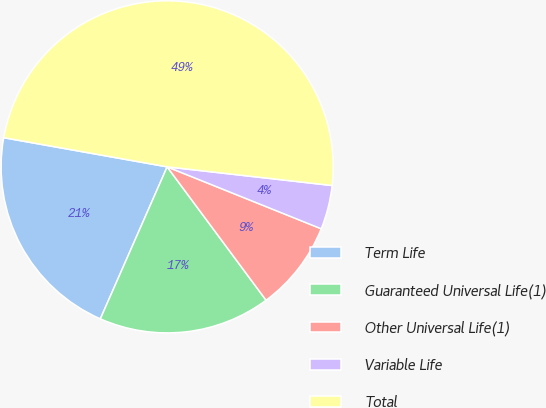<chart> <loc_0><loc_0><loc_500><loc_500><pie_chart><fcel>Term Life<fcel>Guaranteed Universal Life(1)<fcel>Other Universal Life(1)<fcel>Variable Life<fcel>Total<nl><fcel>21.22%<fcel>16.75%<fcel>8.76%<fcel>4.29%<fcel>48.99%<nl></chart> 